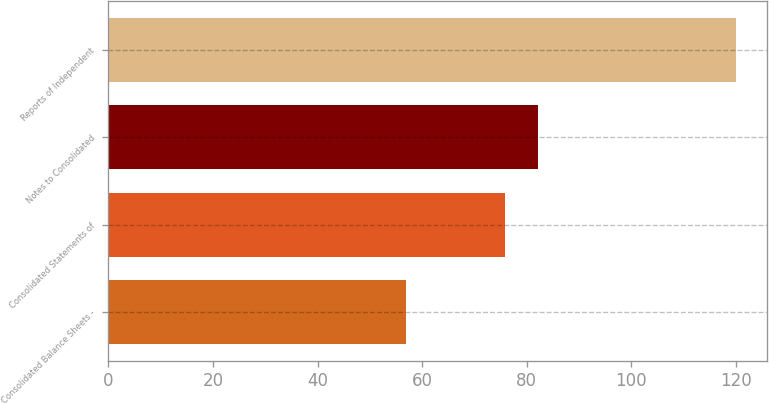Convert chart. <chart><loc_0><loc_0><loc_500><loc_500><bar_chart><fcel>Consolidated Balance Sheets -<fcel>Consolidated Statements of<fcel>Notes to Consolidated<fcel>Reports of Independent<nl><fcel>57<fcel>75.9<fcel>82.2<fcel>120<nl></chart> 